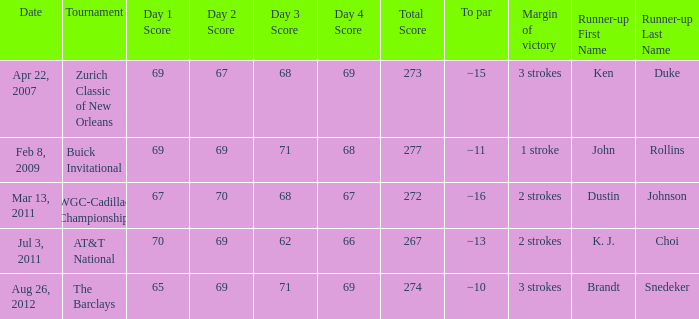What was the victory gap when brandt snedeker was the second-place finisher? 3 strokes. 